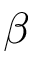Convert formula to latex. <formula><loc_0><loc_0><loc_500><loc_500>\beta</formula> 